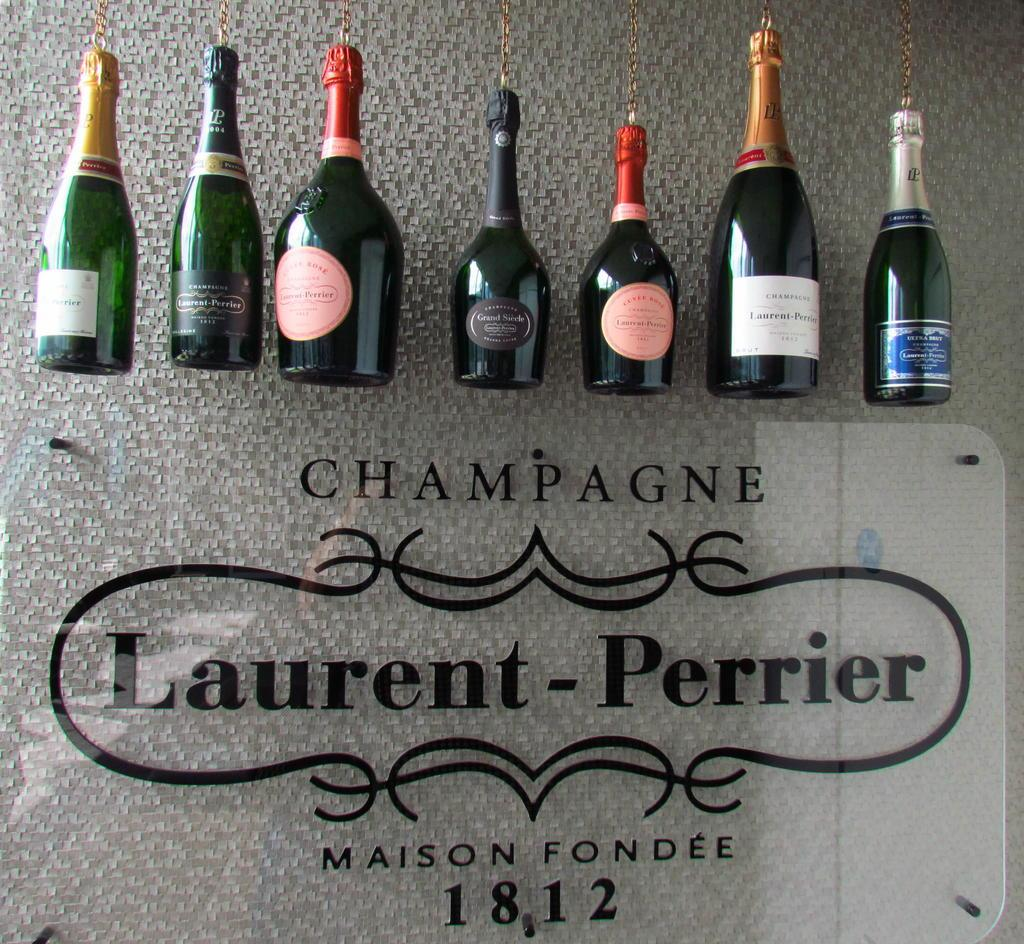Provide a one-sentence caption for the provided image. Champagne bottles on top of a sign that has the year 1812 on it. 